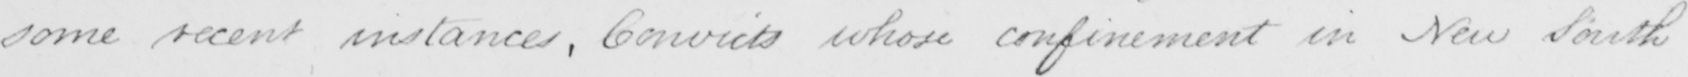Please transcribe the handwritten text in this image. some recent instances , Convicts whose confinement in New South 